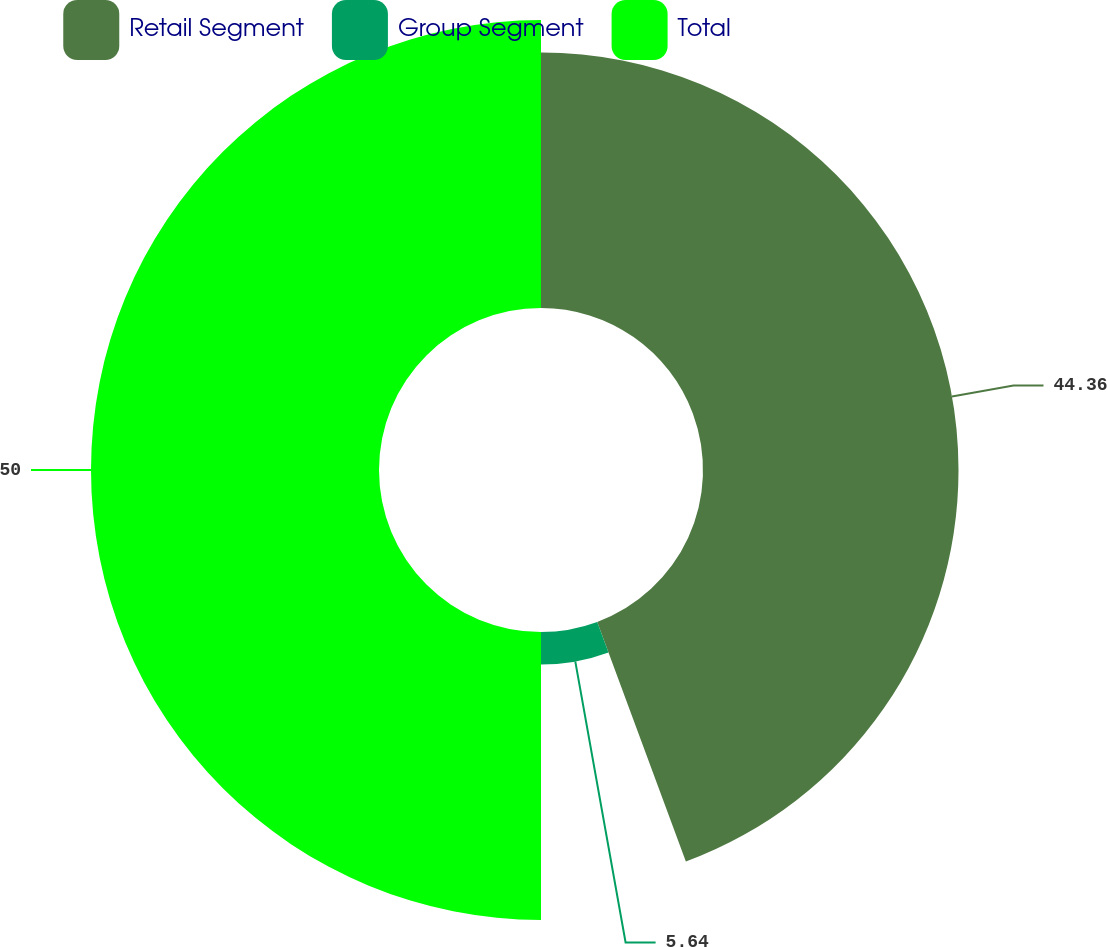<chart> <loc_0><loc_0><loc_500><loc_500><pie_chart><fcel>Retail Segment<fcel>Group Segment<fcel>Total<nl><fcel>44.36%<fcel>5.64%<fcel>50.0%<nl></chart> 